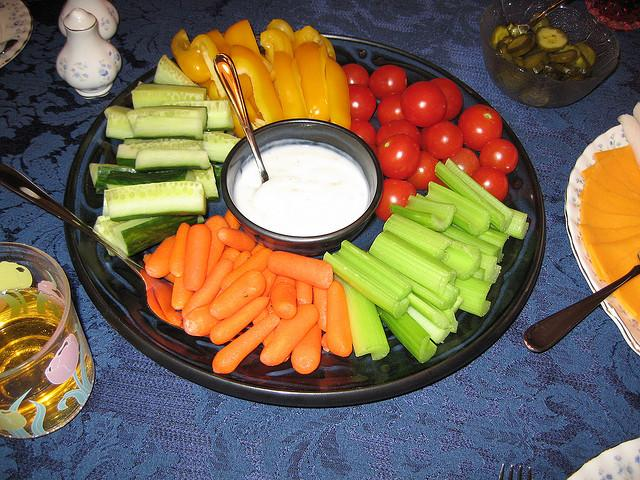What type of utensil is resting in the middle of the bowl in the cup? Please explain your reasoning. spoon. It is utensil used for scooping liquid. 